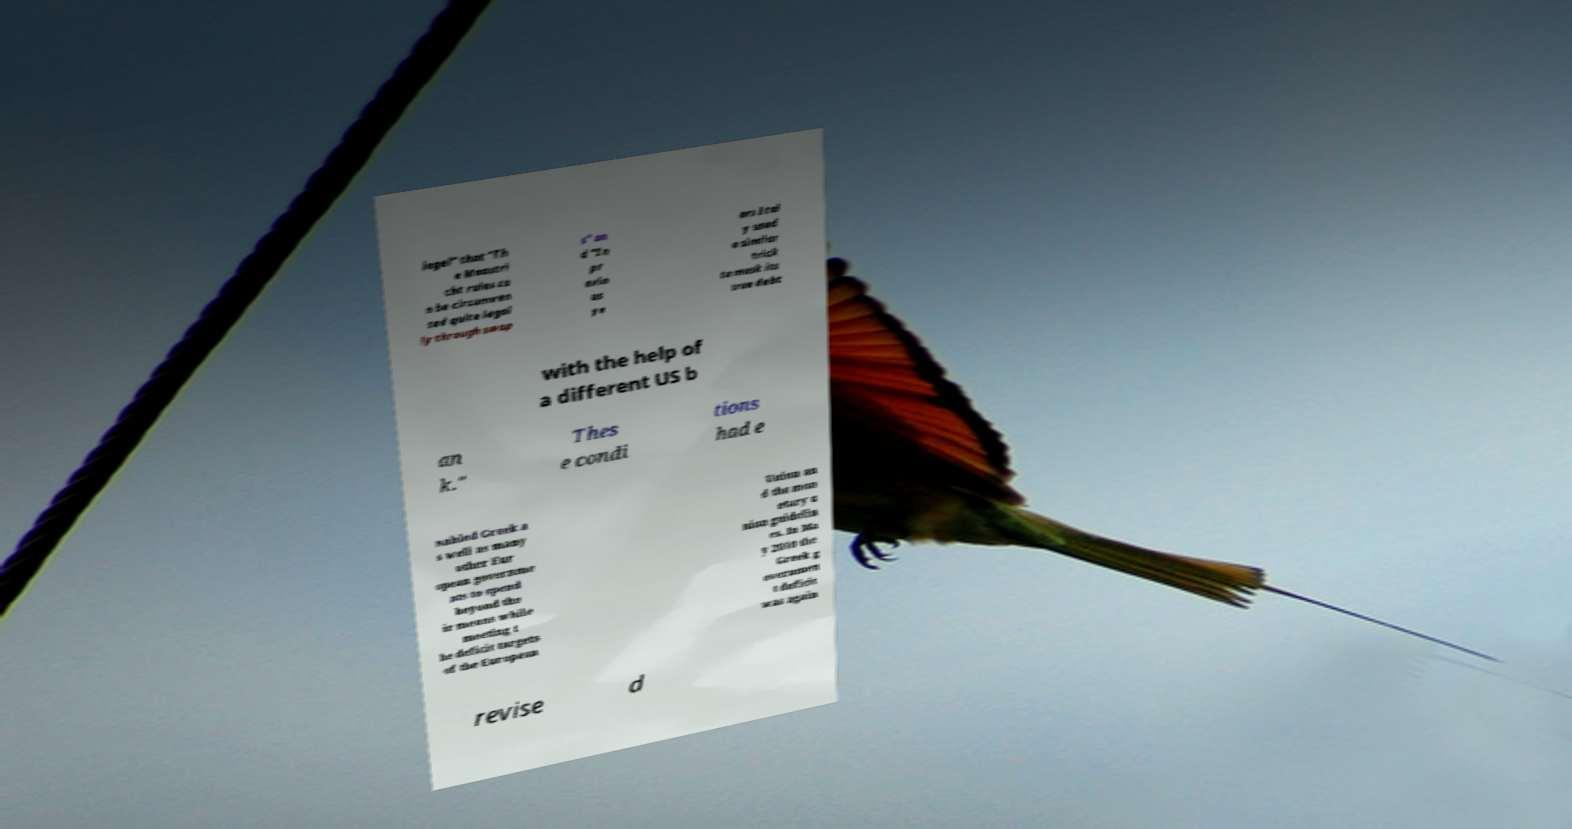Please identify and transcribe the text found in this image. iegel" that "Th e Maastri cht rules ca n be circumven ted quite legal ly through swap s" an d "In pr evio us ye ars Ital y used a similar trick to mask its true debt with the help of a different US b an k." Thes e condi tions had e nabled Greek a s well as many other Eur opean governme nts to spend beyond the ir means while meeting t he deficit targets of the European Union an d the mon etary u nion guidelin es. In Ma y 2010 the Greek g overnmen t deficit was again revise d 